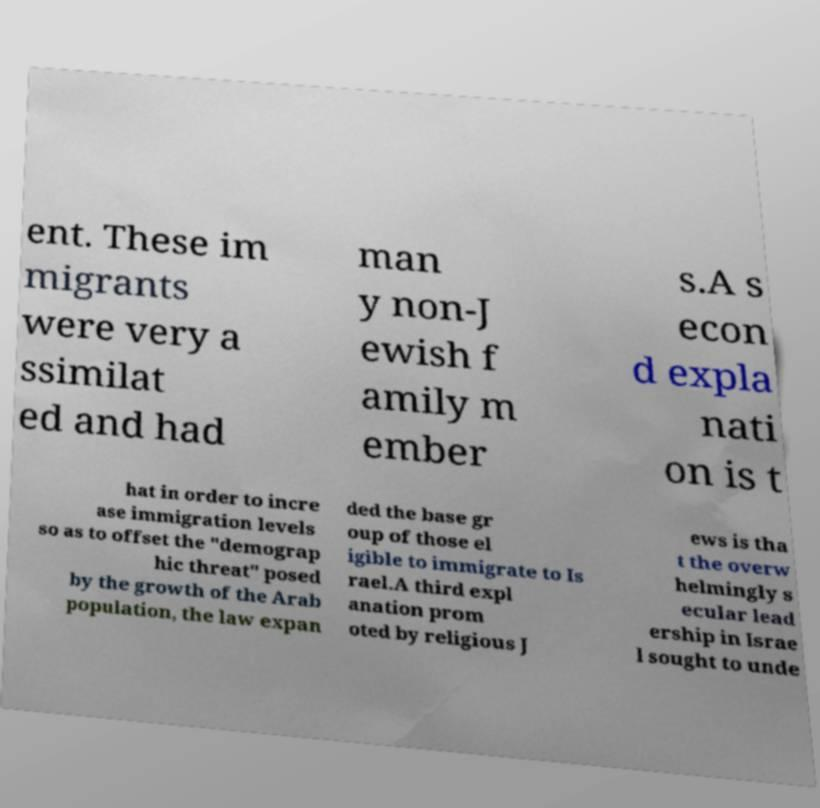Can you read and provide the text displayed in the image?This photo seems to have some interesting text. Can you extract and type it out for me? ent. These im migrants were very a ssimilat ed and had man y non-J ewish f amily m ember s.A s econ d expla nati on is t hat in order to incre ase immigration levels so as to offset the "demograp hic threat" posed by the growth of the Arab population, the law expan ded the base gr oup of those el igible to immigrate to Is rael.A third expl anation prom oted by religious J ews is tha t the overw helmingly s ecular lead ership in Israe l sought to unde 